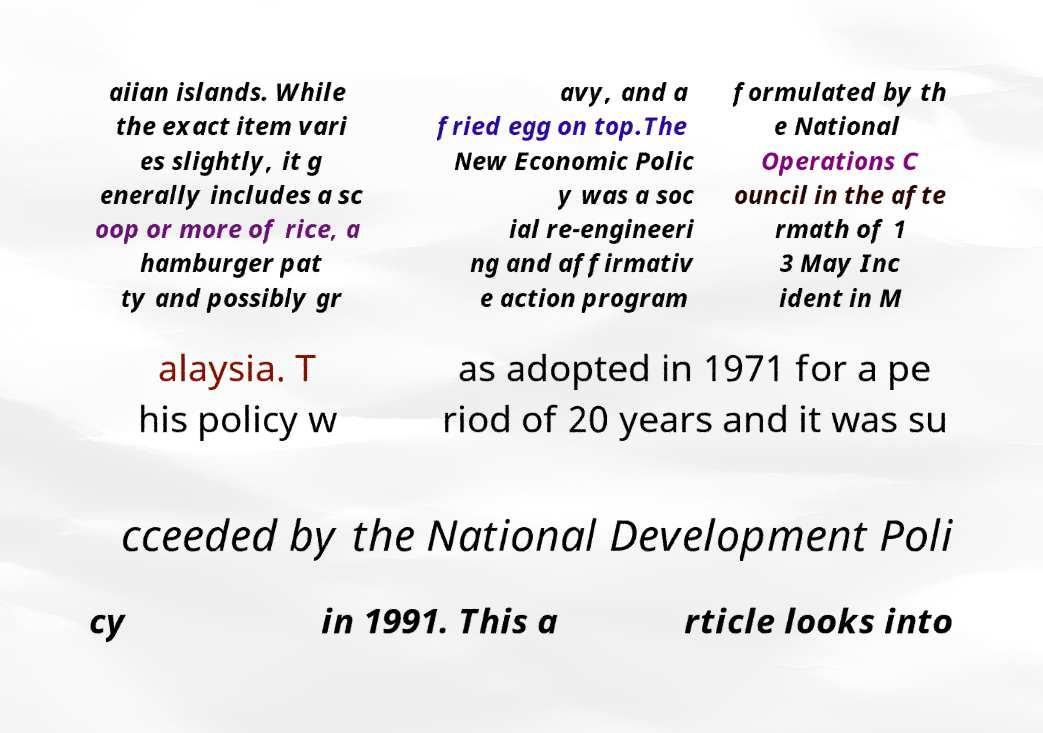Can you accurately transcribe the text from the provided image for me? aiian islands. While the exact item vari es slightly, it g enerally includes a sc oop or more of rice, a hamburger pat ty and possibly gr avy, and a fried egg on top.The New Economic Polic y was a soc ial re-engineeri ng and affirmativ e action program formulated by th e National Operations C ouncil in the afte rmath of 1 3 May Inc ident in M alaysia. T his policy w as adopted in 1971 for a pe riod of 20 years and it was su cceeded by the National Development Poli cy in 1991. This a rticle looks into 